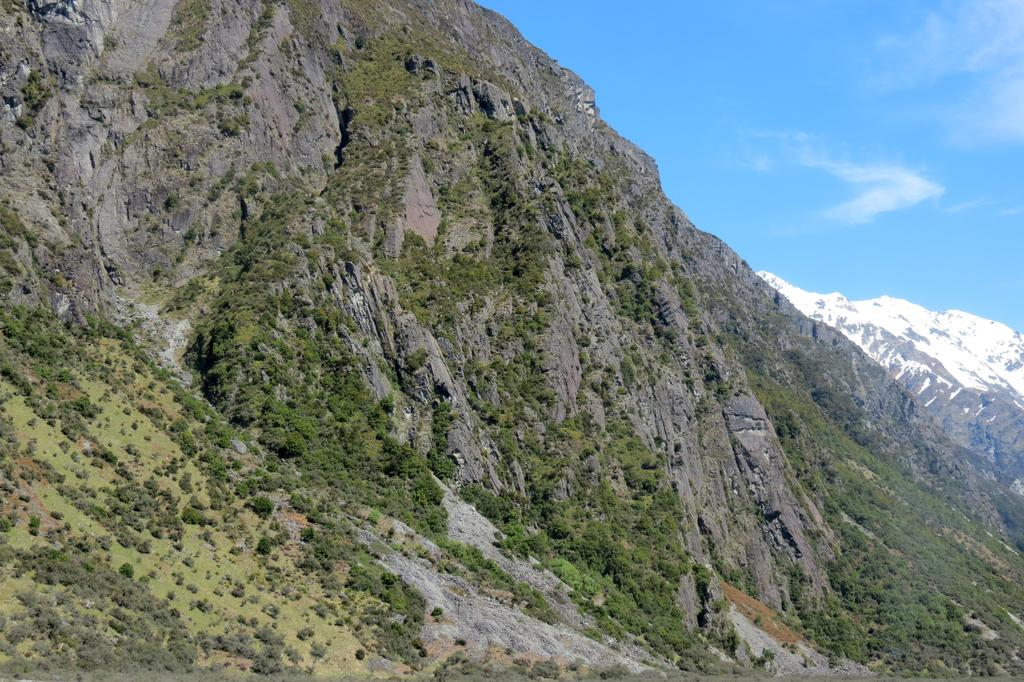What type of vegetation is visible on the ground in the image? There are plants and trees on the ground in the image. What type of natural formation can be seen in the background of the image? There are mountains in the background of the image. What can be seen in the sky in the background of the image? There are clouds in the sky in the background of the image. What type of brass ornament is hanging from the tree in the image? There is no brass ornament present in the image; it features plants, trees, mountains, and clouds. What stage of development can be observed in the plants and trees in the image? The provided facts do not give information about the development stage of the plants and trees in the image. 